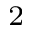Convert formula to latex. <formula><loc_0><loc_0><loc_500><loc_500>^ { 2 }</formula> 